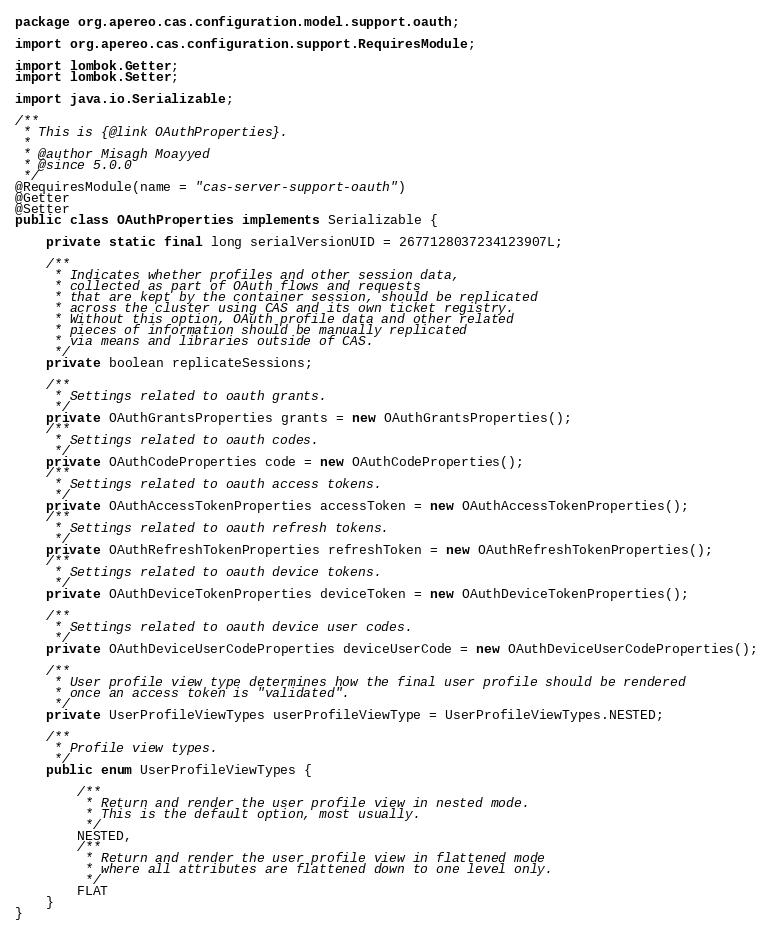Convert code to text. <code><loc_0><loc_0><loc_500><loc_500><_Java_>package org.apereo.cas.configuration.model.support.oauth;

import org.apereo.cas.configuration.support.RequiresModule;

import lombok.Getter;
import lombok.Setter;

import java.io.Serializable;

/**
 * This is {@link OAuthProperties}.
 *
 * @author Misagh Moayyed
 * @since 5.0.0
 */
@RequiresModule(name = "cas-server-support-oauth")
@Getter
@Setter
public class OAuthProperties implements Serializable {

    private static final long serialVersionUID = 2677128037234123907L;

    /**
     * Indicates whether profiles and other session data,
     * collected as part of OAuth flows and requests
     * that are kept by the container session, should be replicated
     * across the cluster using CAS and its own ticket registry.
     * Without this option, OAuth profile data and other related
     * pieces of information should be manually replicated
     * via means and libraries outside of CAS.
     */
    private boolean replicateSessions;

    /**
     * Settings related to oauth grants.
     */
    private OAuthGrantsProperties grants = new OAuthGrantsProperties();
    /**
     * Settings related to oauth codes.
     */
    private OAuthCodeProperties code = new OAuthCodeProperties();
    /**
     * Settings related to oauth access tokens.
     */
    private OAuthAccessTokenProperties accessToken = new OAuthAccessTokenProperties();
    /**
     * Settings related to oauth refresh tokens.
     */
    private OAuthRefreshTokenProperties refreshToken = new OAuthRefreshTokenProperties();
    /**
     * Settings related to oauth device tokens.
     */
    private OAuthDeviceTokenProperties deviceToken = new OAuthDeviceTokenProperties();

    /**
     * Settings related to oauth device user codes.
     */
    private OAuthDeviceUserCodeProperties deviceUserCode = new OAuthDeviceUserCodeProperties();

    /**
     * User profile view type determines how the final user profile should be rendered
     * once an access token is "validated".
     */
    private UserProfileViewTypes userProfileViewType = UserProfileViewTypes.NESTED;

    /**
     * Profile view types.
     */
    public enum UserProfileViewTypes {

        /**
         * Return and render the user profile view in nested mode.
         * This is the default option, most usually.
         */
        NESTED,
        /**
         * Return and render the user profile view in flattened mode
         * where all attributes are flattened down to one level only.
         */
        FLAT
    }
}
</code> 